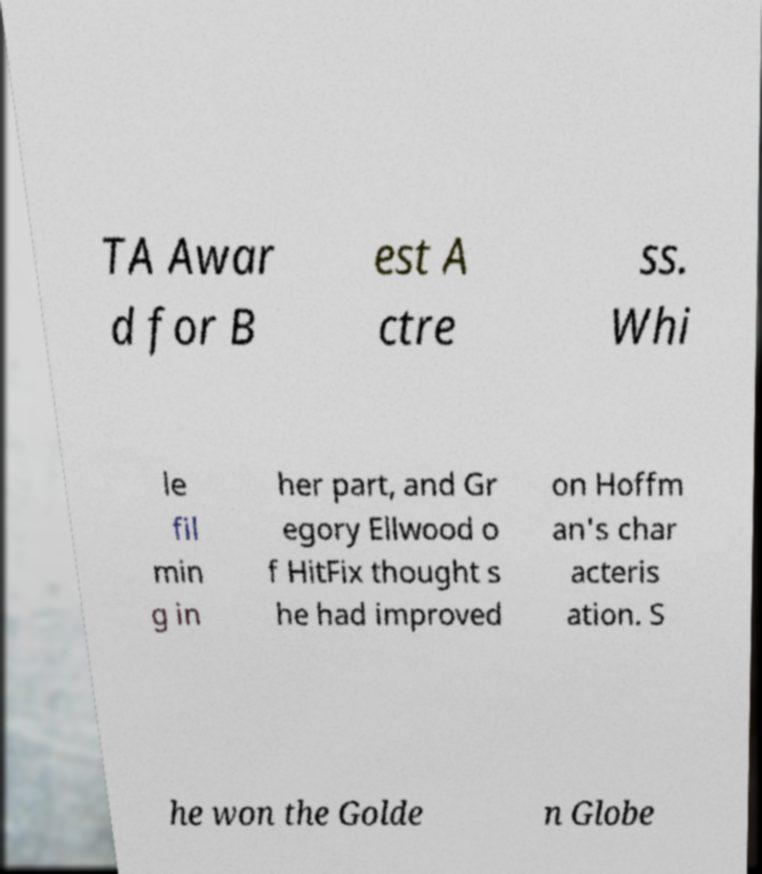For documentation purposes, I need the text within this image transcribed. Could you provide that? TA Awar d for B est A ctre ss. Whi le fil min g in her part, and Gr egory Ellwood o f HitFix thought s he had improved on Hoffm an's char acteris ation. S he won the Golde n Globe 